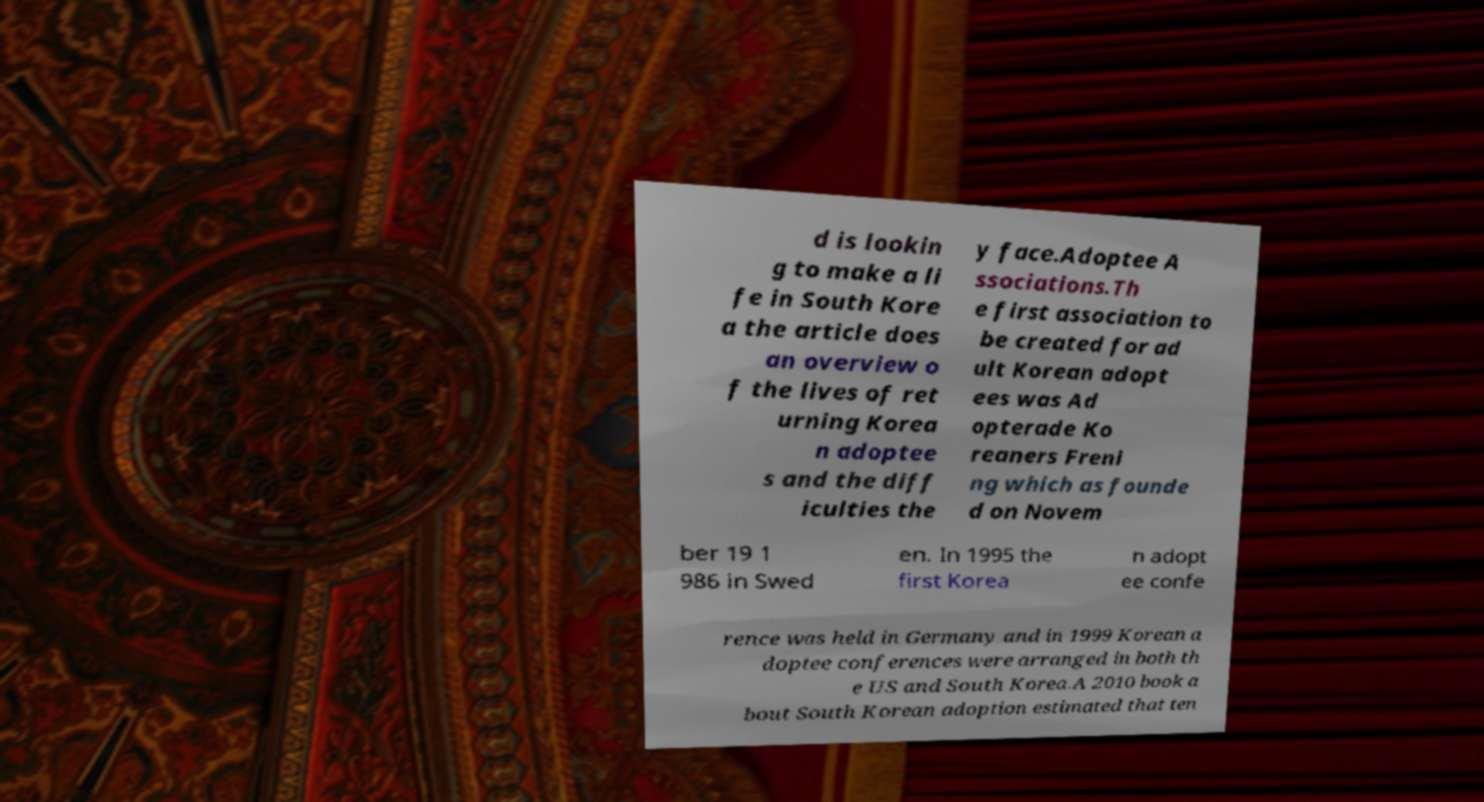Can you read and provide the text displayed in the image?This photo seems to have some interesting text. Can you extract and type it out for me? d is lookin g to make a li fe in South Kore a the article does an overview o f the lives of ret urning Korea n adoptee s and the diff iculties the y face.Adoptee A ssociations.Th e first association to be created for ad ult Korean adopt ees was Ad opterade Ko reaners Freni ng which as founde d on Novem ber 19 1 986 in Swed en. In 1995 the first Korea n adopt ee confe rence was held in Germany and in 1999 Korean a doptee conferences were arranged in both th e US and South Korea.A 2010 book a bout South Korean adoption estimated that ten 